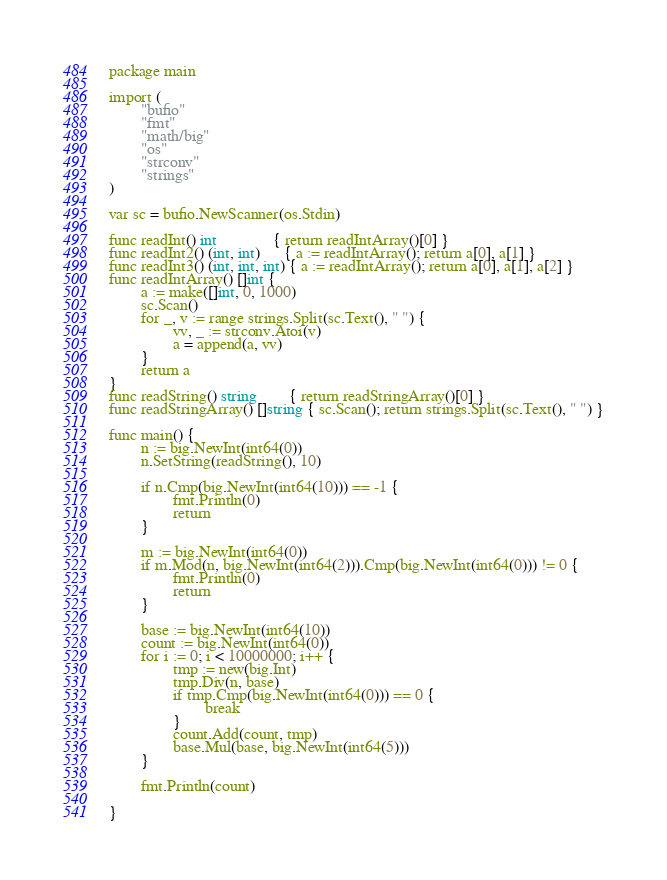<code> <loc_0><loc_0><loc_500><loc_500><_Go_>package main

import (
        "bufio"
        "fmt"
        "math/big"
        "os"
        "strconv"
        "strings"
)

var sc = bufio.NewScanner(os.Stdin)

func readInt() int              { return readIntArray()[0] }
func readInt2() (int, int)      { a := readIntArray(); return a[0], a[1] }
func readInt3() (int, int, int) { a := readIntArray(); return a[0], a[1], a[2] }
func readIntArray() []int {
        a := make([]int, 0, 1000)
        sc.Scan()
        for _, v := range strings.Split(sc.Text(), " ") {
                vv, _ := strconv.Atoi(v)
                a = append(a, vv)
        }
        return a
}
func readString() string        { return readStringArray()[0] }
func readStringArray() []string { sc.Scan(); return strings.Split(sc.Text(), " ") }

func main() {
        n := big.NewInt(int64(0))
        n.SetString(readString(), 10)

        if n.Cmp(big.NewInt(int64(10))) == -1 {
                fmt.Println(0)
                return
        }

        m := big.NewInt(int64(0))
        if m.Mod(n, big.NewInt(int64(2))).Cmp(big.NewInt(int64(0))) != 0 {
                fmt.Println(0)
                return
        }

        base := big.NewInt(int64(10))
        count := big.NewInt(int64(0))
        for i := 0; i < 10000000; i++ {
                tmp := new(big.Int)
                tmp.Div(n, base)
                if tmp.Cmp(big.NewInt(int64(0))) == 0 {
                        break
                }
                count.Add(count, tmp)
                base.Mul(base, big.NewInt(int64(5)))
        }

        fmt.Println(count)

}

</code> 